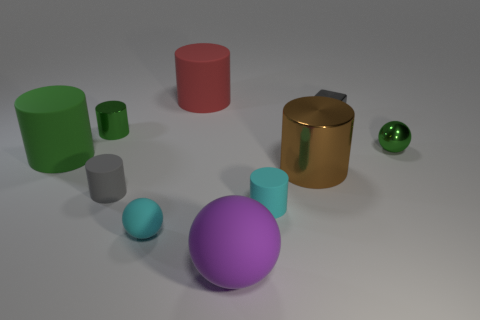Subtract all purple blocks. How many green cylinders are left? 2 Subtract all big matte balls. How many balls are left? 2 Subtract 2 cylinders. How many cylinders are left? 4 Subtract all red cylinders. How many cylinders are left? 5 Subtract all brown cylinders. Subtract all cyan blocks. How many cylinders are left? 5 Subtract all balls. How many objects are left? 7 Add 4 big red rubber objects. How many big red rubber objects are left? 5 Add 8 big green cylinders. How many big green cylinders exist? 9 Subtract 0 cyan cubes. How many objects are left? 10 Subtract all small gray matte blocks. Subtract all small gray shiny things. How many objects are left? 9 